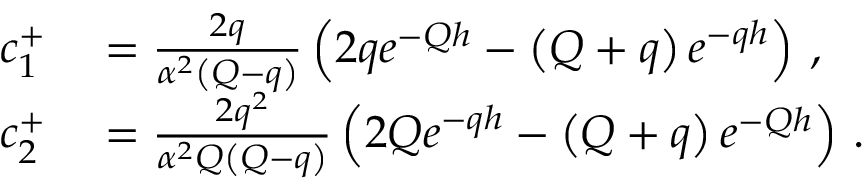Convert formula to latex. <formula><loc_0><loc_0><loc_500><loc_500>\begin{array} { r l } { c _ { 1 } ^ { + } } & = \frac { 2 q } { \alpha ^ { 2 } \left ( Q - q \right ) } \left ( 2 q e ^ { - Q h } - \left ( Q + q \right ) e ^ { - q h } \right ) \, , } \\ { c _ { 2 } ^ { + } } & = \frac { 2 q ^ { 2 } } { \alpha ^ { 2 } Q \left ( Q - q \right ) } \left ( 2 Q e ^ { - q h } - \left ( Q + q \right ) e ^ { - Q h } \right ) \, . } \end{array}</formula> 